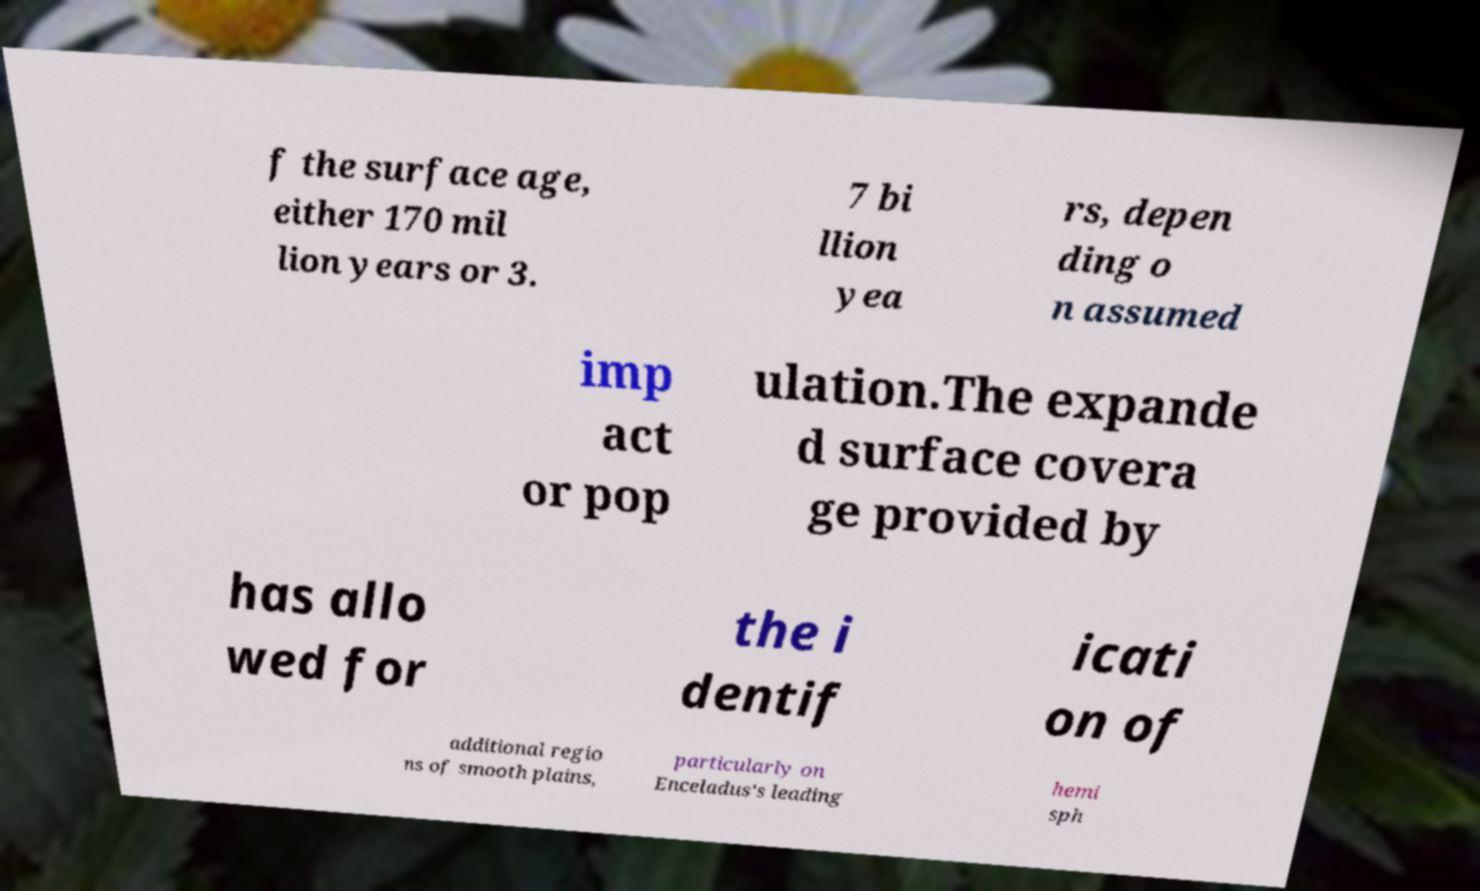Can you read and provide the text displayed in the image?This photo seems to have some interesting text. Can you extract and type it out for me? f the surface age, either 170 mil lion years or 3. 7 bi llion yea rs, depen ding o n assumed imp act or pop ulation.The expande d surface covera ge provided by has allo wed for the i dentif icati on of additional regio ns of smooth plains, particularly on Enceladus's leading hemi sph 